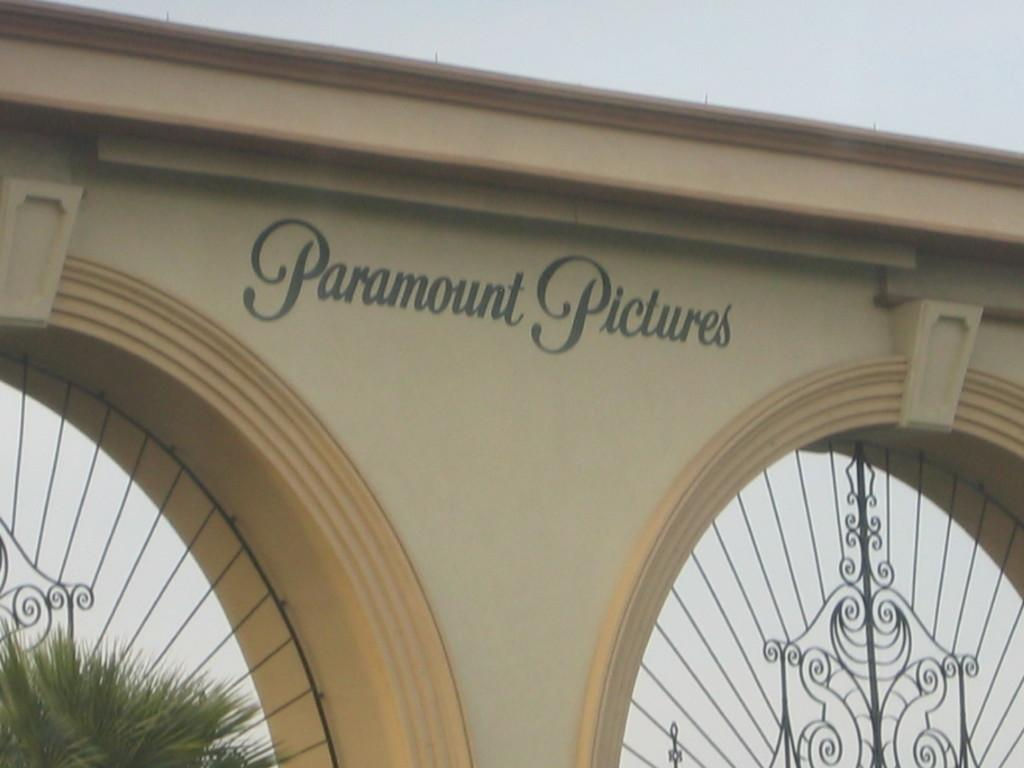What is the main structure in the center of the image? There is a wall in the center of the image. What is located near the wall? There is a plant near the wall. What else can be seen in the center of the image? There are fences in the center of the image. What is written on the wall? The wall has the text "Paramount Pictures" written on it. What can be seen in the background of the image? The sky is visible in the background of the image. How many horses are talking to each other in the image? There are no horses present in the image, and therefore no such interaction can be observed. 